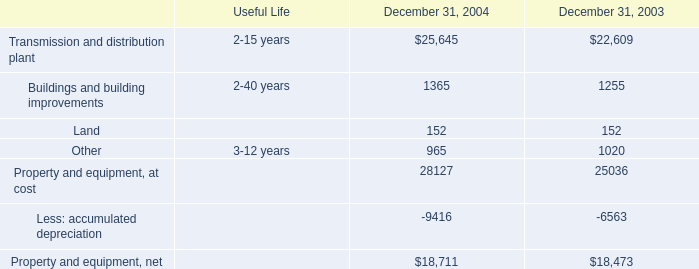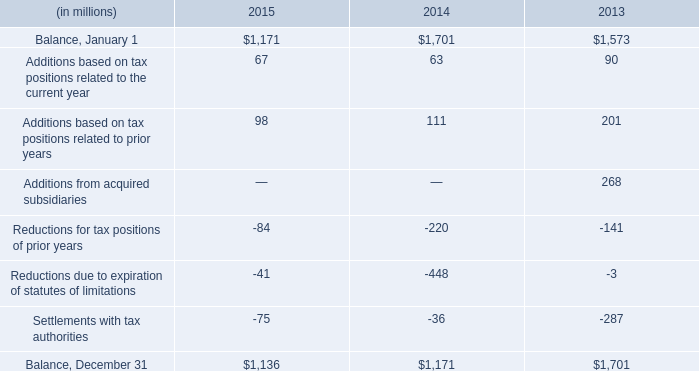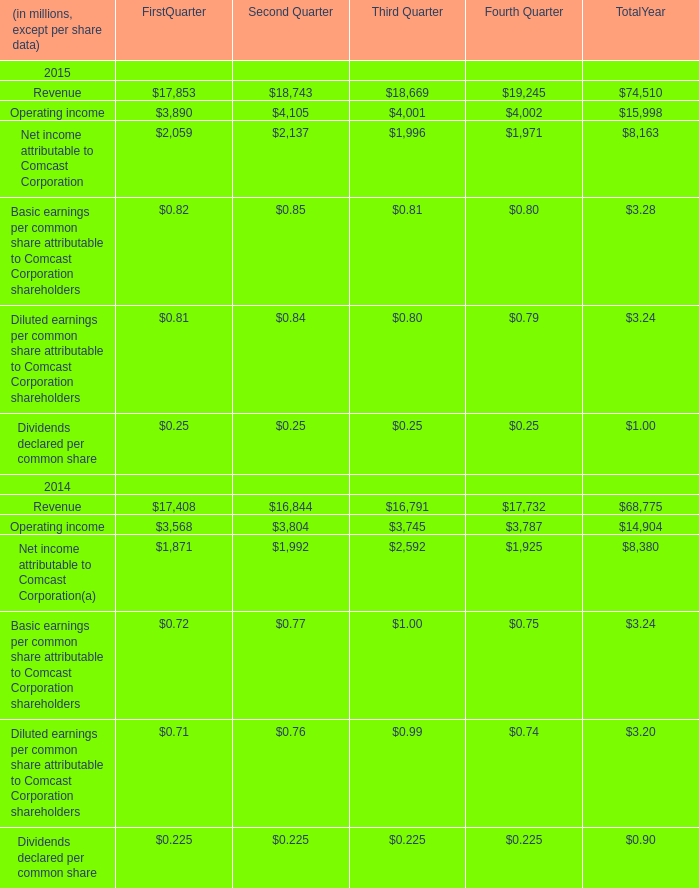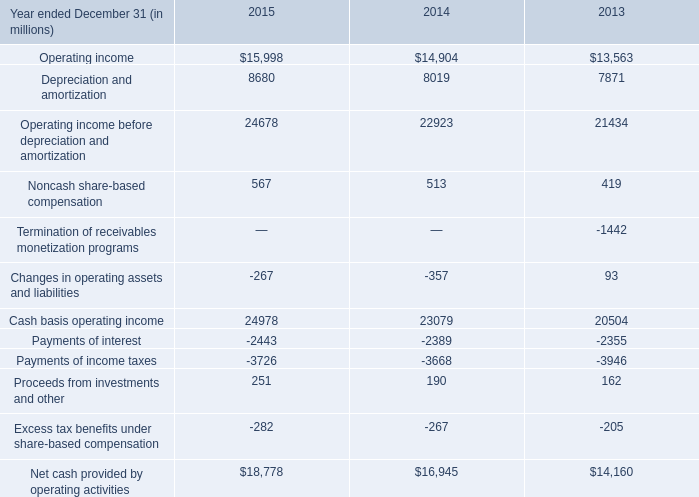What is the sum of Net income attributable to Comcast Corporation of Second Quarter, Operating income before depreciation and amortization of 2014, and Balance, January 1 of 2013 ? 
Computations: ((2137.0 + 22923.0) + 1573.0)
Answer: 26633.0. 